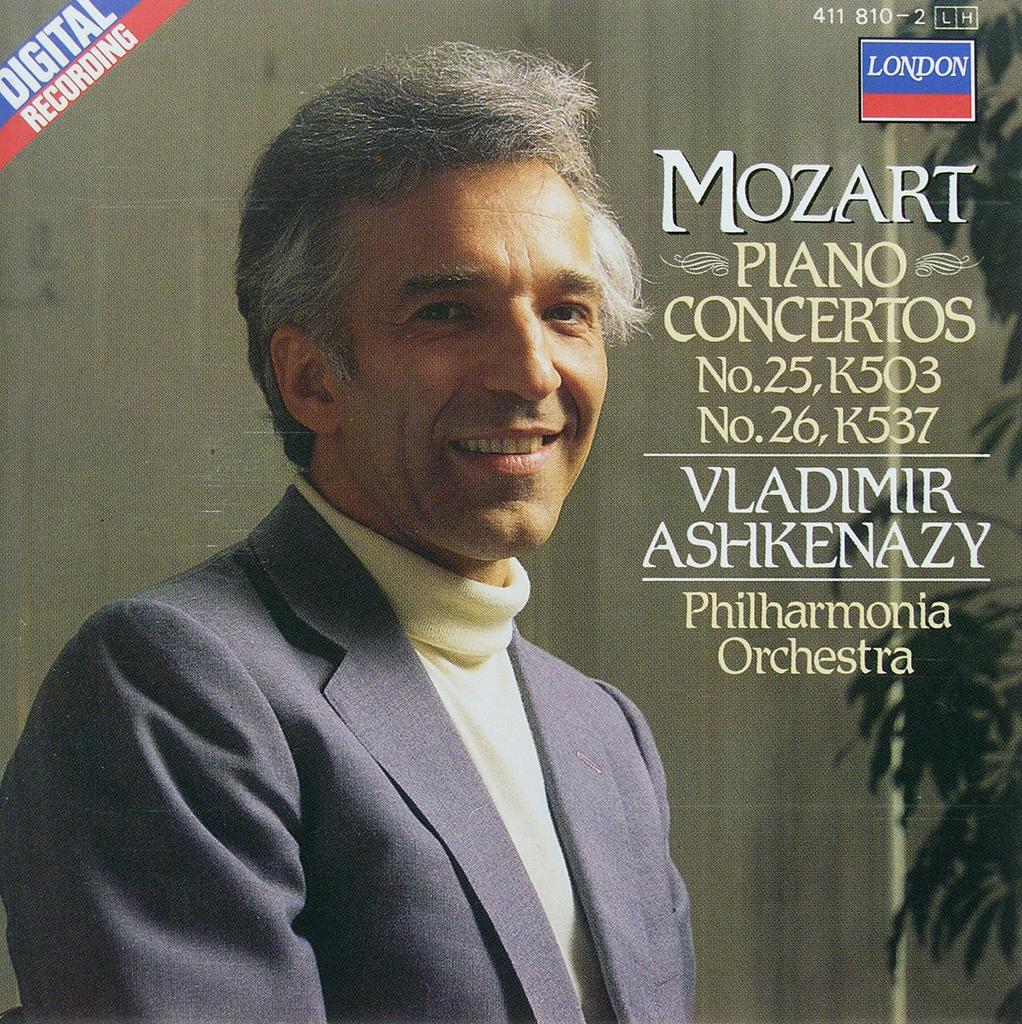<image>
Summarize the visual content of the image. A CD with the image of a man on it titled Mozart. 